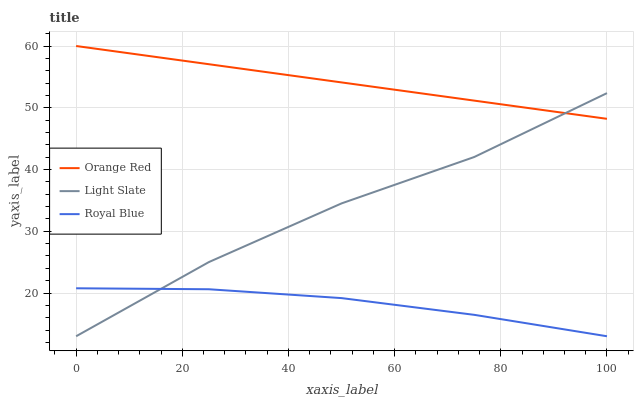Does Royal Blue have the minimum area under the curve?
Answer yes or no. Yes. Does Orange Red have the maximum area under the curve?
Answer yes or no. Yes. Does Orange Red have the minimum area under the curve?
Answer yes or no. No. Does Royal Blue have the maximum area under the curve?
Answer yes or no. No. Is Orange Red the smoothest?
Answer yes or no. Yes. Is Light Slate the roughest?
Answer yes or no. Yes. Is Royal Blue the smoothest?
Answer yes or no. No. Is Royal Blue the roughest?
Answer yes or no. No. Does Light Slate have the lowest value?
Answer yes or no. Yes. Does Orange Red have the lowest value?
Answer yes or no. No. Does Orange Red have the highest value?
Answer yes or no. Yes. Does Royal Blue have the highest value?
Answer yes or no. No. Is Royal Blue less than Orange Red?
Answer yes or no. Yes. Is Orange Red greater than Royal Blue?
Answer yes or no. Yes. Does Royal Blue intersect Light Slate?
Answer yes or no. Yes. Is Royal Blue less than Light Slate?
Answer yes or no. No. Is Royal Blue greater than Light Slate?
Answer yes or no. No. Does Royal Blue intersect Orange Red?
Answer yes or no. No. 